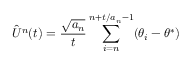Convert formula to latex. <formula><loc_0><loc_0><loc_500><loc_500>{ \hat { U } } ^ { n } ( t ) = { \frac { \sqrt { a _ { n } } } { t } } \sum _ { i = n } ^ { n + t / a _ { n } - 1 } ( \theta _ { i } - \theta ^ { * } )</formula> 